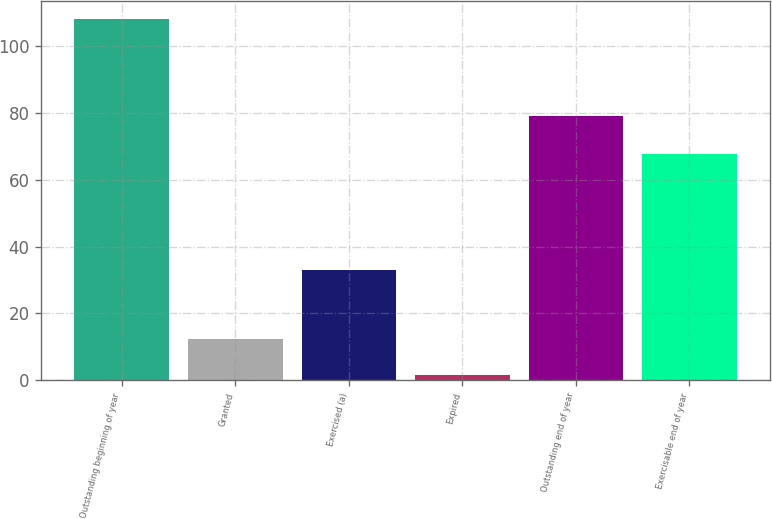Convert chart. <chart><loc_0><loc_0><loc_500><loc_500><bar_chart><fcel>Outstanding beginning of year<fcel>Granted<fcel>Exercised (a)<fcel>Expired<fcel>Outstanding end of year<fcel>Exercisable end of year<nl><fcel>108<fcel>12.24<fcel>33.1<fcel>1.6<fcel>79.1<fcel>67.6<nl></chart> 